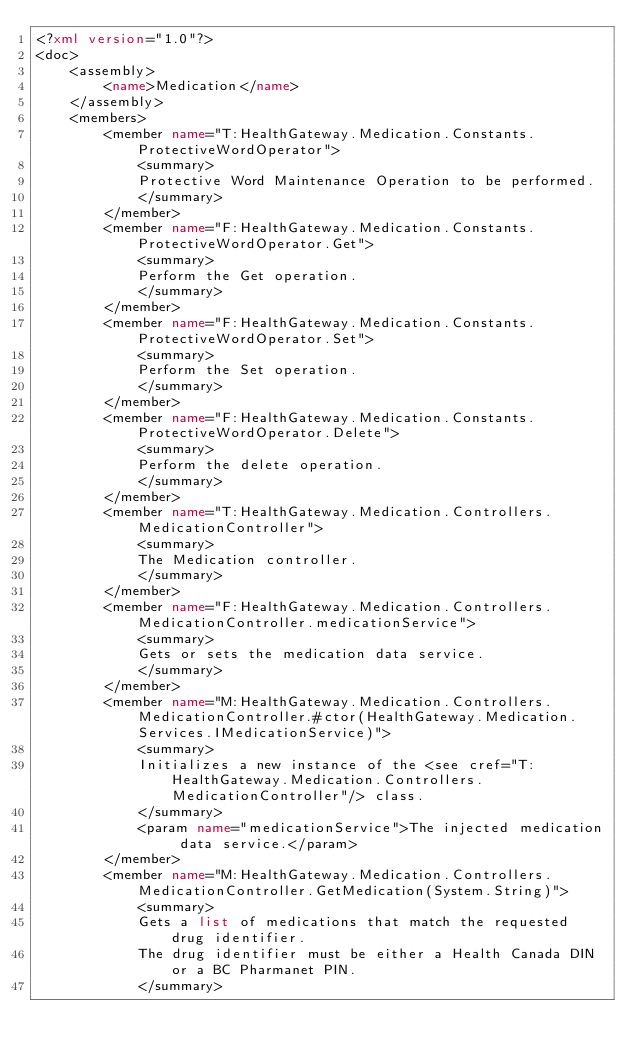<code> <loc_0><loc_0><loc_500><loc_500><_XML_><?xml version="1.0"?>
<doc>
    <assembly>
        <name>Medication</name>
    </assembly>
    <members>
        <member name="T:HealthGateway.Medication.Constants.ProtectiveWordOperator">
            <summary>
            Protective Word Maintenance Operation to be performed.
            </summary>
        </member>
        <member name="F:HealthGateway.Medication.Constants.ProtectiveWordOperator.Get">
            <summary>
            Perform the Get operation.
            </summary>
        </member>
        <member name="F:HealthGateway.Medication.Constants.ProtectiveWordOperator.Set">
            <summary>
            Perform the Set operation.
            </summary>
        </member>
        <member name="F:HealthGateway.Medication.Constants.ProtectiveWordOperator.Delete">
            <summary>
            Perform the delete operation.
            </summary>
        </member>
        <member name="T:HealthGateway.Medication.Controllers.MedicationController">
            <summary>
            The Medication controller.
            </summary>
        </member>
        <member name="F:HealthGateway.Medication.Controllers.MedicationController.medicationService">
            <summary>
            Gets or sets the medication data service.
            </summary>
        </member>
        <member name="M:HealthGateway.Medication.Controllers.MedicationController.#ctor(HealthGateway.Medication.Services.IMedicationService)">
            <summary>
            Initializes a new instance of the <see cref="T:HealthGateway.Medication.Controllers.MedicationController"/> class.
            </summary>
            <param name="medicationService">The injected medication data service.</param>
        </member>
        <member name="M:HealthGateway.Medication.Controllers.MedicationController.GetMedication(System.String)">
            <summary>
            Gets a list of medications that match the requested drug identifier.
            The drug identifier must be either a Health Canada DIN or a BC Pharmanet PIN.
            </summary></code> 